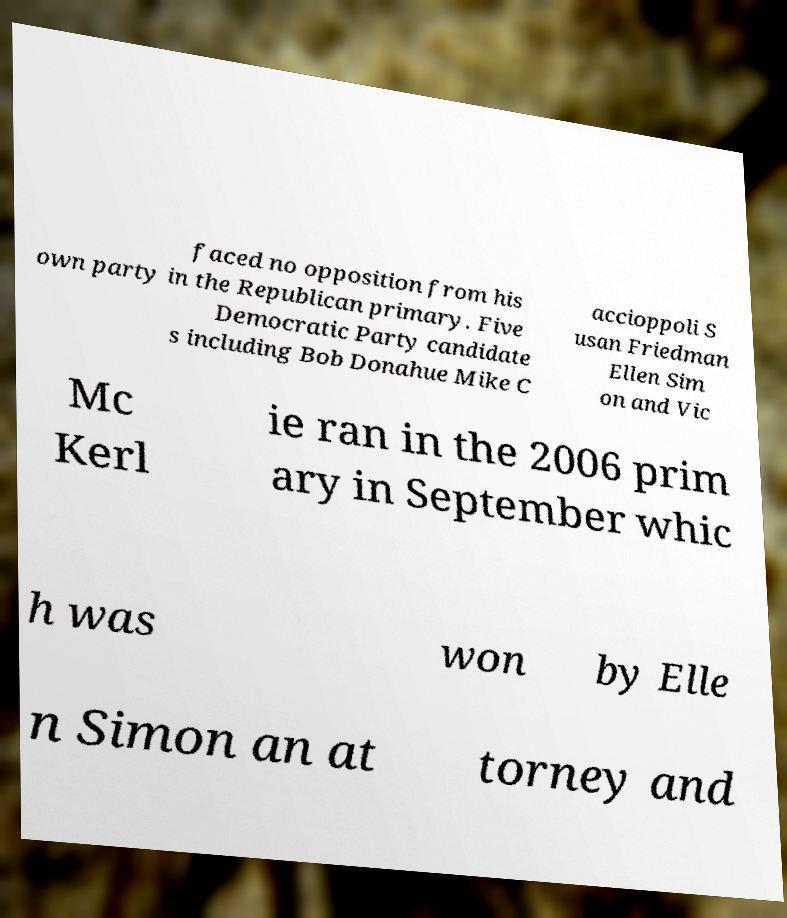Can you read and provide the text displayed in the image?This photo seems to have some interesting text. Can you extract and type it out for me? faced no opposition from his own party in the Republican primary. Five Democratic Party candidate s including Bob Donahue Mike C accioppoli S usan Friedman Ellen Sim on and Vic Mc Kerl ie ran in the 2006 prim ary in September whic h was won by Elle n Simon an at torney and 